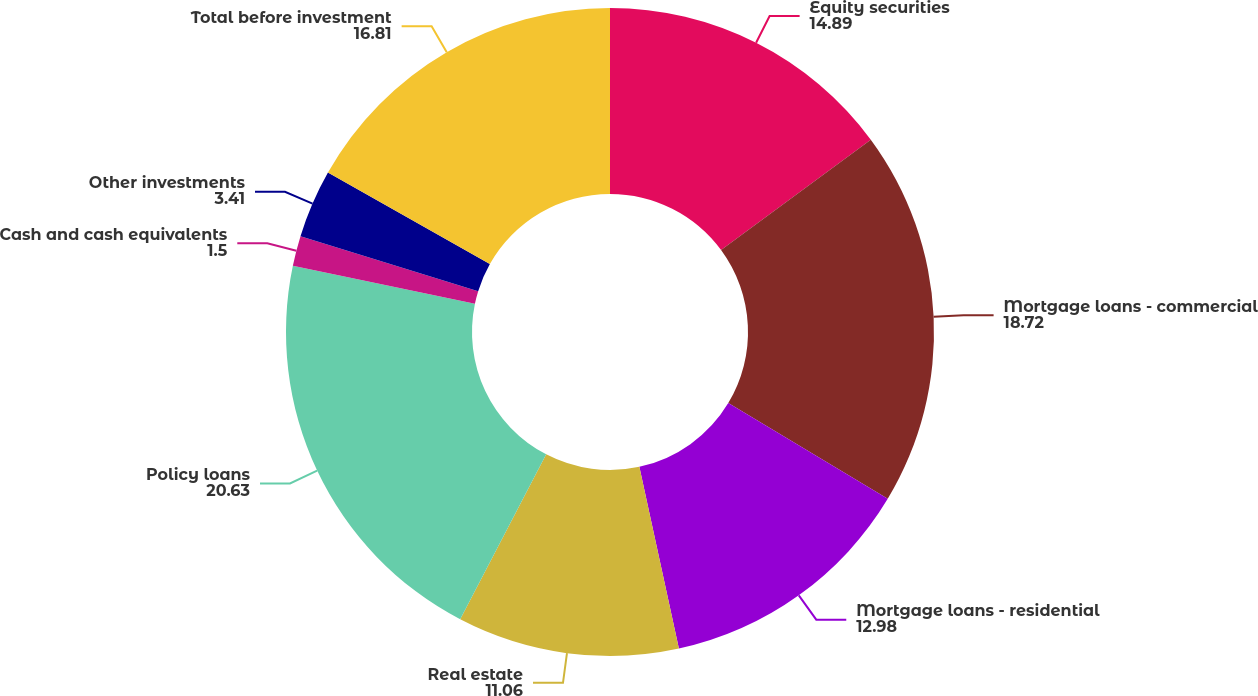Convert chart to OTSL. <chart><loc_0><loc_0><loc_500><loc_500><pie_chart><fcel>Equity securities<fcel>Mortgage loans - commercial<fcel>Mortgage loans - residential<fcel>Real estate<fcel>Policy loans<fcel>Cash and cash equivalents<fcel>Other investments<fcel>Total before investment<nl><fcel>14.89%<fcel>18.72%<fcel>12.98%<fcel>11.06%<fcel>20.63%<fcel>1.5%<fcel>3.41%<fcel>16.81%<nl></chart> 